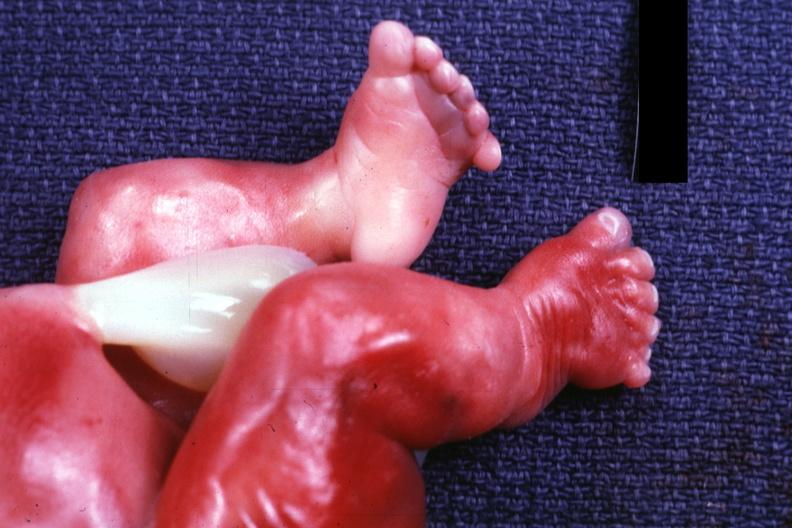what are too short?
Answer the question using a single word or phrase. Newborn with renal polycystic disease legs 